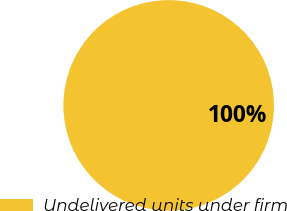Convert chart. <chart><loc_0><loc_0><loc_500><loc_500><pie_chart><fcel>Undelivered units under firm<nl><fcel>100.0%<nl></chart> 